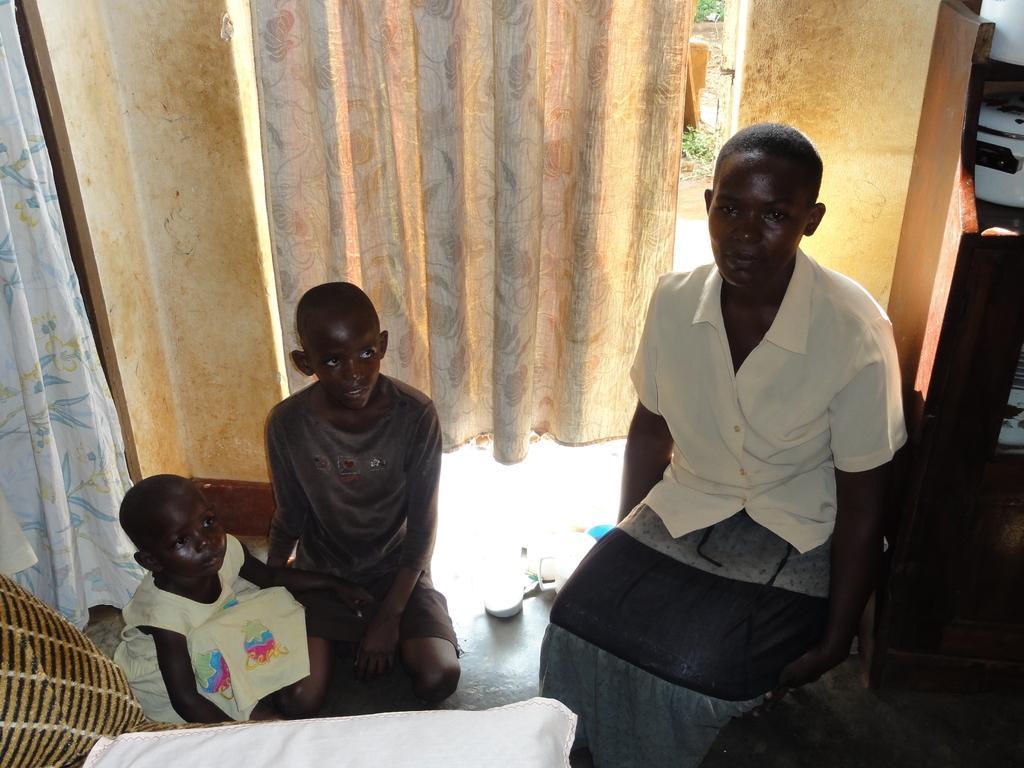Can you describe this image briefly? This picture shows the inner view of a room. There are two curtains, one woman sitting on the chair, two chairs, two children sitting on the floor, some objects on the floor, one object on the ground, one white cloth on the chair, and some plants on the ground. 